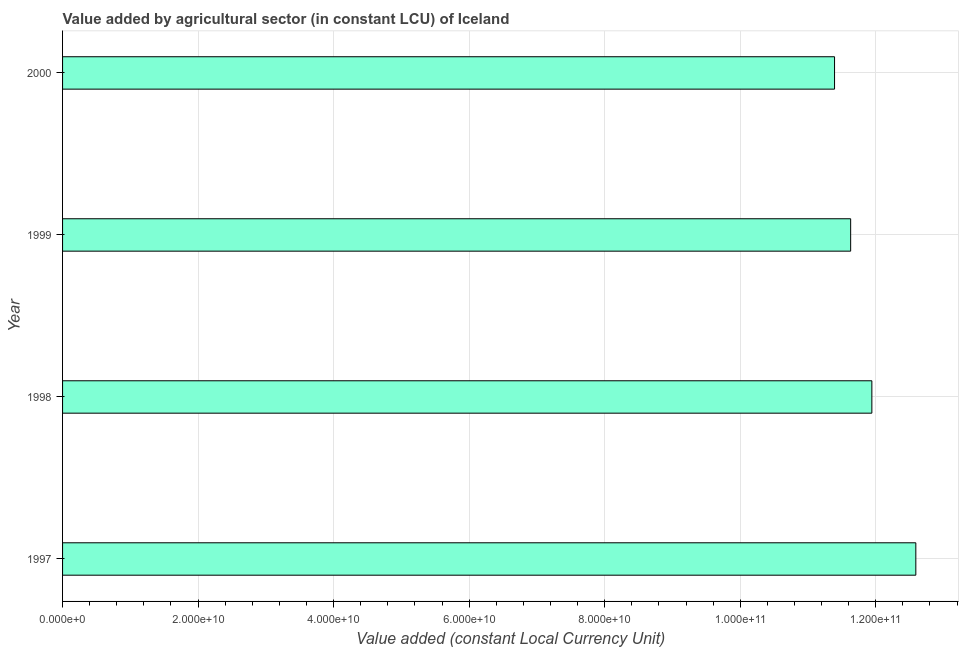Does the graph contain any zero values?
Provide a succinct answer. No. What is the title of the graph?
Your response must be concise. Value added by agricultural sector (in constant LCU) of Iceland. What is the label or title of the X-axis?
Provide a succinct answer. Value added (constant Local Currency Unit). What is the value added by agriculture sector in 1997?
Your response must be concise. 1.26e+11. Across all years, what is the maximum value added by agriculture sector?
Keep it short and to the point. 1.26e+11. Across all years, what is the minimum value added by agriculture sector?
Your answer should be very brief. 1.14e+11. In which year was the value added by agriculture sector maximum?
Provide a succinct answer. 1997. What is the sum of the value added by agriculture sector?
Your answer should be very brief. 4.76e+11. What is the difference between the value added by agriculture sector in 1997 and 2000?
Give a very brief answer. 1.20e+1. What is the average value added by agriculture sector per year?
Offer a very short reply. 1.19e+11. What is the median value added by agriculture sector?
Your response must be concise. 1.18e+11. In how many years, is the value added by agriculture sector greater than 36000000000 LCU?
Your response must be concise. 4. What is the ratio of the value added by agriculture sector in 1997 to that in 1998?
Your response must be concise. 1.05. What is the difference between the highest and the second highest value added by agriculture sector?
Offer a terse response. 6.49e+09. Is the sum of the value added by agriculture sector in 1997 and 1999 greater than the maximum value added by agriculture sector across all years?
Offer a very short reply. Yes. What is the difference between the highest and the lowest value added by agriculture sector?
Your answer should be very brief. 1.20e+1. How many years are there in the graph?
Offer a terse response. 4. What is the difference between two consecutive major ticks on the X-axis?
Ensure brevity in your answer.  2.00e+1. Are the values on the major ticks of X-axis written in scientific E-notation?
Give a very brief answer. Yes. What is the Value added (constant Local Currency Unit) in 1997?
Offer a terse response. 1.26e+11. What is the Value added (constant Local Currency Unit) in 1998?
Give a very brief answer. 1.19e+11. What is the Value added (constant Local Currency Unit) of 1999?
Your answer should be very brief. 1.16e+11. What is the Value added (constant Local Currency Unit) of 2000?
Ensure brevity in your answer.  1.14e+11. What is the difference between the Value added (constant Local Currency Unit) in 1997 and 1998?
Your answer should be very brief. 6.49e+09. What is the difference between the Value added (constant Local Currency Unit) in 1997 and 1999?
Make the answer very short. 9.62e+09. What is the difference between the Value added (constant Local Currency Unit) in 1997 and 2000?
Provide a succinct answer. 1.20e+1. What is the difference between the Value added (constant Local Currency Unit) in 1998 and 1999?
Your response must be concise. 3.13e+09. What is the difference between the Value added (constant Local Currency Unit) in 1998 and 2000?
Your response must be concise. 5.51e+09. What is the difference between the Value added (constant Local Currency Unit) in 1999 and 2000?
Your answer should be compact. 2.38e+09. What is the ratio of the Value added (constant Local Currency Unit) in 1997 to that in 1998?
Your answer should be compact. 1.05. What is the ratio of the Value added (constant Local Currency Unit) in 1997 to that in 1999?
Make the answer very short. 1.08. What is the ratio of the Value added (constant Local Currency Unit) in 1997 to that in 2000?
Offer a very short reply. 1.1. What is the ratio of the Value added (constant Local Currency Unit) in 1998 to that in 2000?
Make the answer very short. 1.05. What is the ratio of the Value added (constant Local Currency Unit) in 1999 to that in 2000?
Make the answer very short. 1.02. 